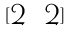Convert formula to latex. <formula><loc_0><loc_0><loc_500><loc_500>[ \begin{matrix} 2 & 2 \end{matrix} ]</formula> 